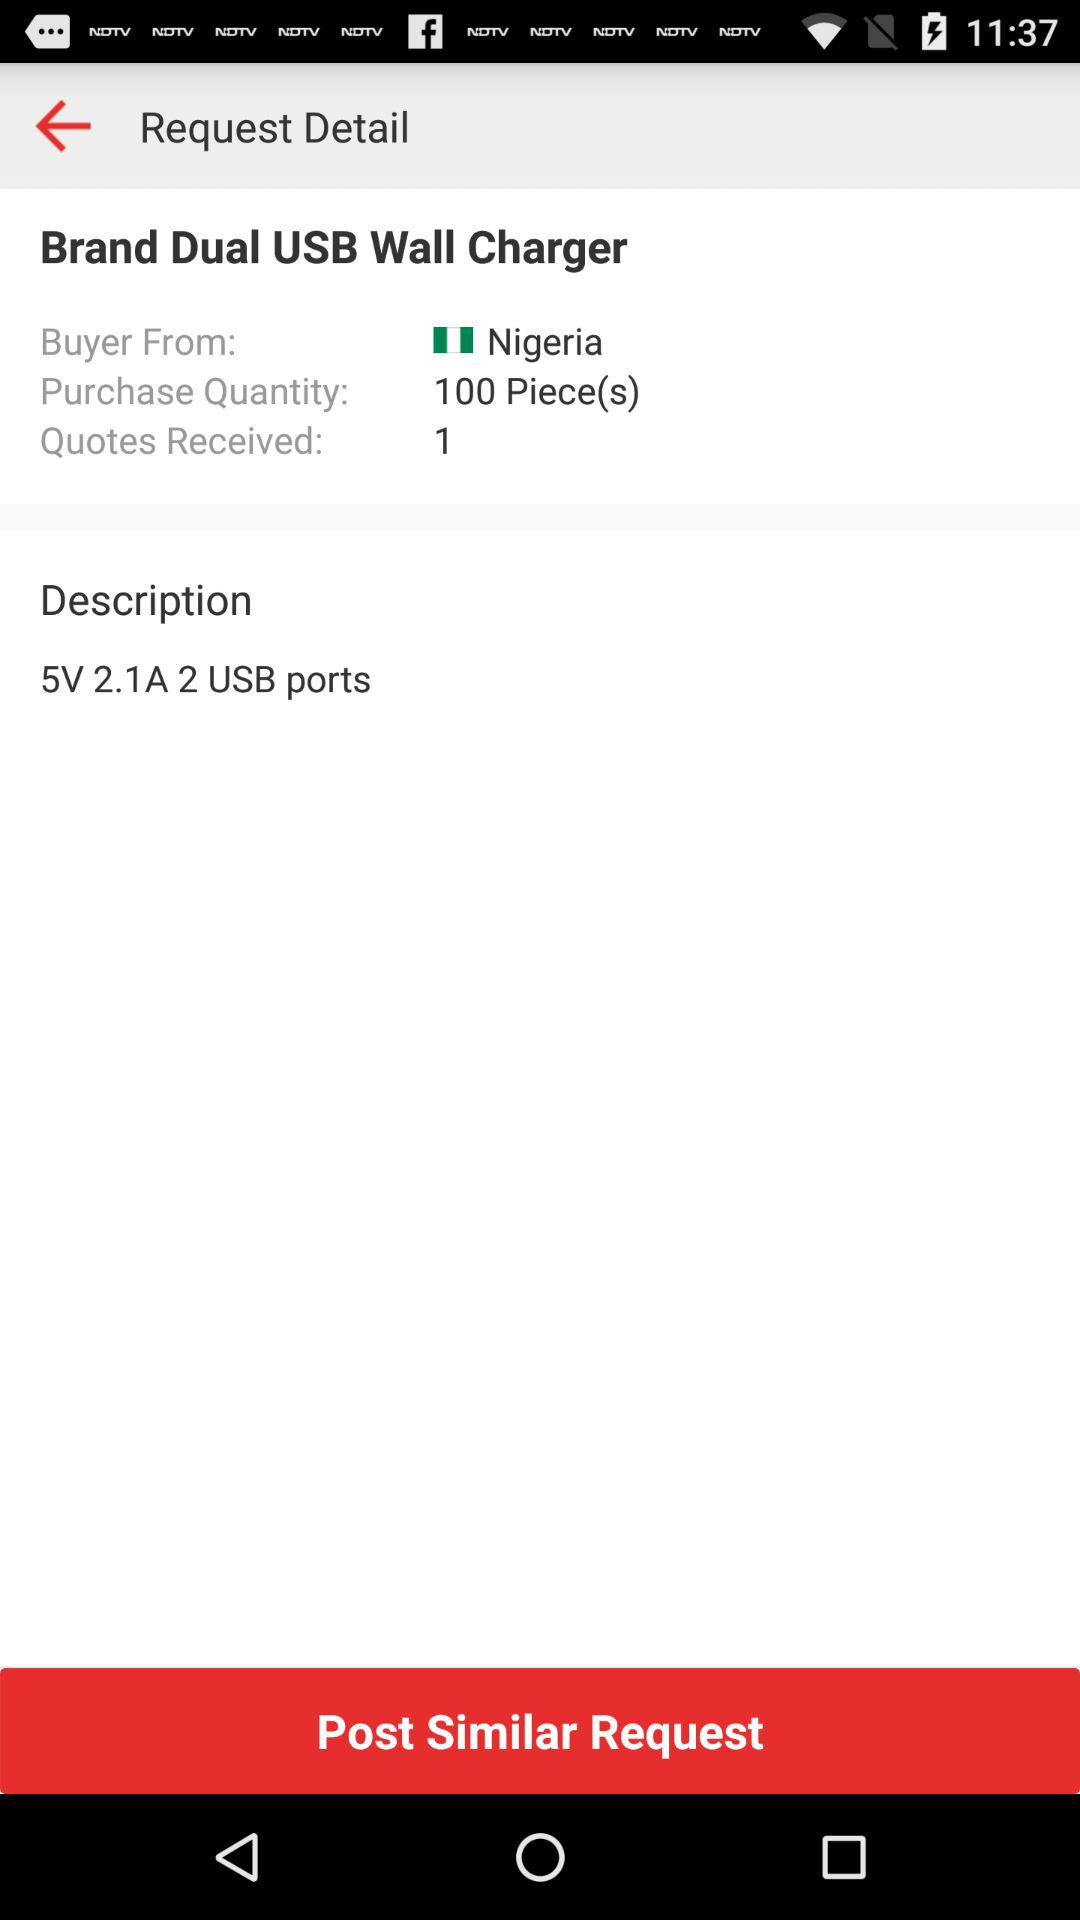What is the description? The description is "5V 2.1A 2 USB ports". 